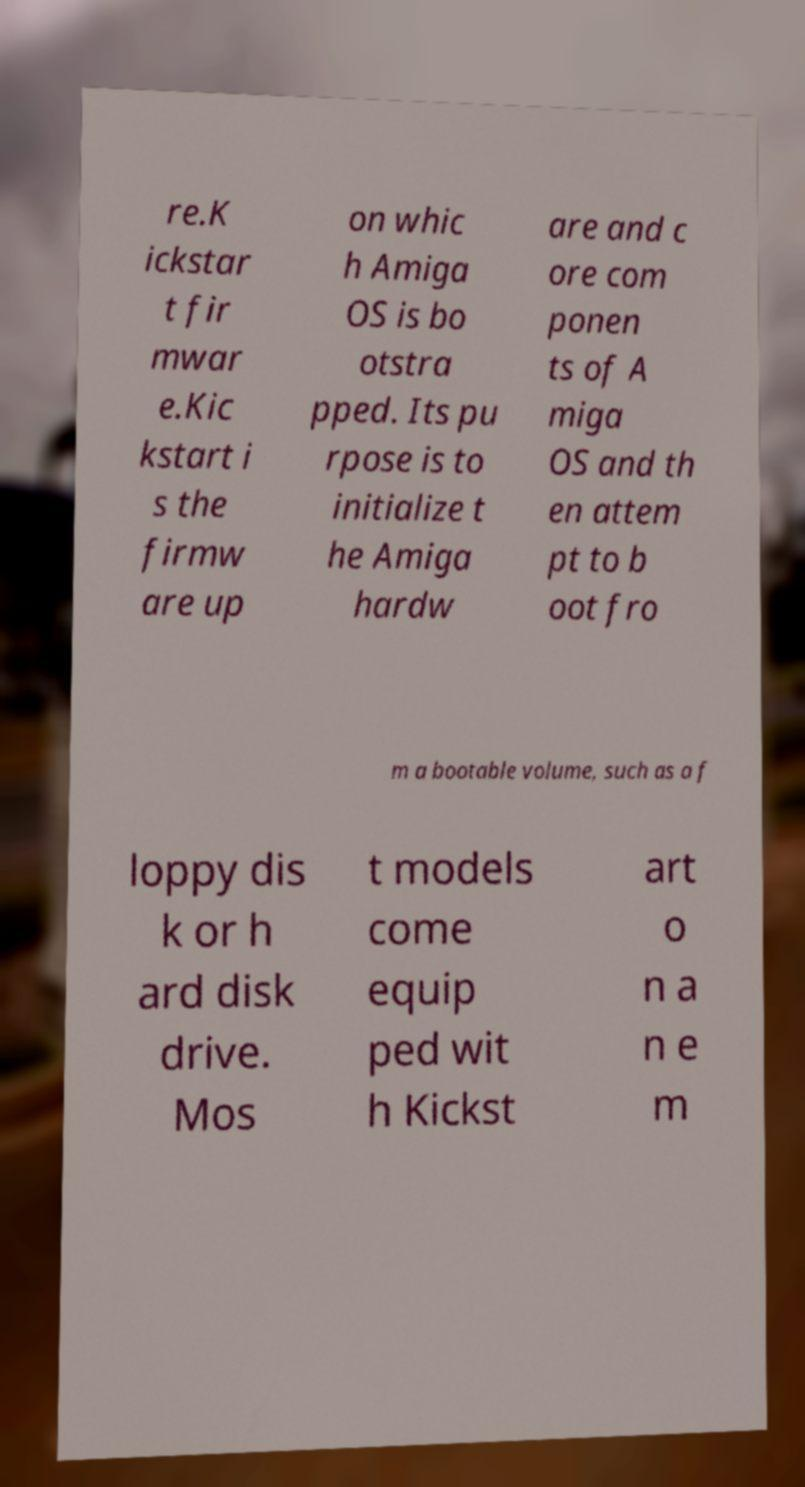There's text embedded in this image that I need extracted. Can you transcribe it verbatim? re.K ickstar t fir mwar e.Kic kstart i s the firmw are up on whic h Amiga OS is bo otstra pped. Its pu rpose is to initialize t he Amiga hardw are and c ore com ponen ts of A miga OS and th en attem pt to b oot fro m a bootable volume, such as a f loppy dis k or h ard disk drive. Mos t models come equip ped wit h Kickst art o n a n e m 